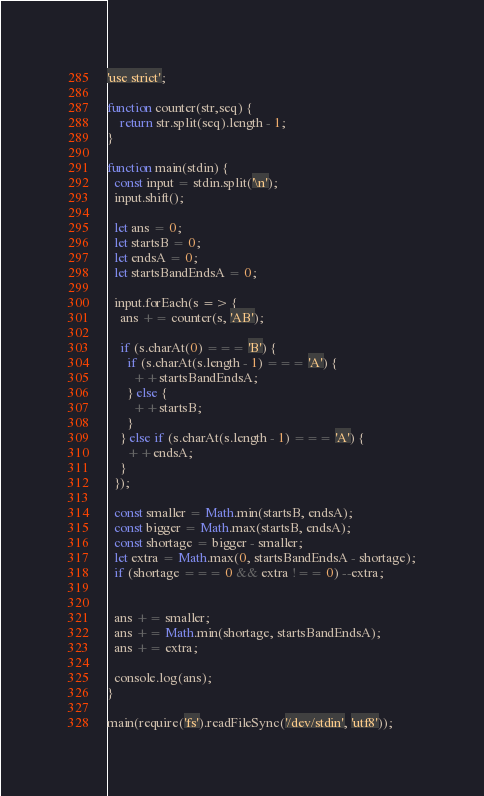Convert code to text. <code><loc_0><loc_0><loc_500><loc_500><_JavaScript_>'use strict';

function counter(str,seq) {
    return str.split(seq).length - 1;
}

function main(stdin) {
  const input = stdin.split('\n');
  input.shift();

  let ans = 0;
  let startsB = 0;
  let endsA = 0;
  let startsBandEndsA = 0;

  input.forEach(s => {
    ans += counter(s, 'AB');

    if (s.charAt(0) === 'B') {
      if (s.charAt(s.length - 1) === 'A') {
        ++startsBandEndsA;
      } else {
        ++startsB;
      }
    } else if (s.charAt(s.length - 1) === 'A') {
      ++endsA;
    }
  });

  const smaller = Math.min(startsB, endsA);
  const bigger = Math.max(startsB, endsA);
  const shortage = bigger - smaller;
  let extra = Math.max(0, startsBandEndsA - shortage);
  if (shortage === 0 && extra !== 0) --extra;
  

  ans += smaller;
  ans += Math.min(shortage, startsBandEndsA);
  ans += extra;

  console.log(ans);
}

main(require('fs').readFileSync('/dev/stdin', 'utf8'));
</code> 